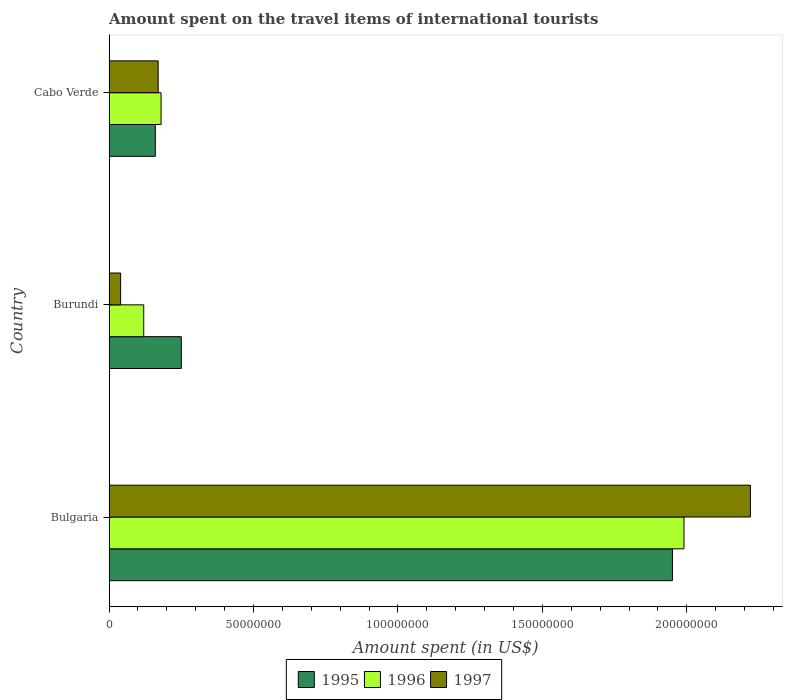How many different coloured bars are there?
Give a very brief answer. 3. How many groups of bars are there?
Your answer should be very brief. 3. Are the number of bars per tick equal to the number of legend labels?
Your answer should be compact. Yes. How many bars are there on the 2nd tick from the bottom?
Provide a short and direct response. 3. What is the label of the 2nd group of bars from the top?
Your answer should be very brief. Burundi. In how many cases, is the number of bars for a given country not equal to the number of legend labels?
Keep it short and to the point. 0. What is the amount spent on the travel items of international tourists in 1997 in Cabo Verde?
Offer a very short reply. 1.70e+07. Across all countries, what is the maximum amount spent on the travel items of international tourists in 1997?
Your answer should be very brief. 2.22e+08. Across all countries, what is the minimum amount spent on the travel items of international tourists in 1996?
Your response must be concise. 1.20e+07. In which country was the amount spent on the travel items of international tourists in 1996 minimum?
Your response must be concise. Burundi. What is the total amount spent on the travel items of international tourists in 1997 in the graph?
Provide a short and direct response. 2.43e+08. What is the difference between the amount spent on the travel items of international tourists in 1997 in Bulgaria and that in Cabo Verde?
Your response must be concise. 2.05e+08. What is the difference between the amount spent on the travel items of international tourists in 1995 in Burundi and the amount spent on the travel items of international tourists in 1997 in Cabo Verde?
Ensure brevity in your answer.  8.00e+06. What is the average amount spent on the travel items of international tourists in 1997 per country?
Keep it short and to the point. 8.10e+07. What is the difference between the amount spent on the travel items of international tourists in 1995 and amount spent on the travel items of international tourists in 1996 in Bulgaria?
Provide a short and direct response. -4.00e+06. In how many countries, is the amount spent on the travel items of international tourists in 1997 greater than 100000000 US$?
Your response must be concise. 1. What is the ratio of the amount spent on the travel items of international tourists in 1997 in Bulgaria to that in Burundi?
Your answer should be compact. 55.5. Is the amount spent on the travel items of international tourists in 1995 in Burundi less than that in Cabo Verde?
Provide a succinct answer. No. Is the difference between the amount spent on the travel items of international tourists in 1995 in Bulgaria and Cabo Verde greater than the difference between the amount spent on the travel items of international tourists in 1996 in Bulgaria and Cabo Verde?
Give a very brief answer. No. What is the difference between the highest and the second highest amount spent on the travel items of international tourists in 1996?
Offer a very short reply. 1.81e+08. What is the difference between the highest and the lowest amount spent on the travel items of international tourists in 1996?
Offer a very short reply. 1.87e+08. How many bars are there?
Provide a succinct answer. 9. How many countries are there in the graph?
Your answer should be very brief. 3. What is the difference between two consecutive major ticks on the X-axis?
Provide a succinct answer. 5.00e+07. Are the values on the major ticks of X-axis written in scientific E-notation?
Provide a succinct answer. No. How many legend labels are there?
Make the answer very short. 3. What is the title of the graph?
Your answer should be very brief. Amount spent on the travel items of international tourists. Does "1991" appear as one of the legend labels in the graph?
Your answer should be compact. No. What is the label or title of the X-axis?
Ensure brevity in your answer.  Amount spent (in US$). What is the Amount spent (in US$) of 1995 in Bulgaria?
Your response must be concise. 1.95e+08. What is the Amount spent (in US$) of 1996 in Bulgaria?
Your response must be concise. 1.99e+08. What is the Amount spent (in US$) in 1997 in Bulgaria?
Your answer should be compact. 2.22e+08. What is the Amount spent (in US$) of 1995 in Burundi?
Keep it short and to the point. 2.50e+07. What is the Amount spent (in US$) of 1997 in Burundi?
Your response must be concise. 4.00e+06. What is the Amount spent (in US$) of 1995 in Cabo Verde?
Your answer should be compact. 1.60e+07. What is the Amount spent (in US$) of 1996 in Cabo Verde?
Ensure brevity in your answer.  1.80e+07. What is the Amount spent (in US$) of 1997 in Cabo Verde?
Provide a succinct answer. 1.70e+07. Across all countries, what is the maximum Amount spent (in US$) in 1995?
Ensure brevity in your answer.  1.95e+08. Across all countries, what is the maximum Amount spent (in US$) of 1996?
Offer a very short reply. 1.99e+08. Across all countries, what is the maximum Amount spent (in US$) of 1997?
Offer a very short reply. 2.22e+08. Across all countries, what is the minimum Amount spent (in US$) of 1995?
Give a very brief answer. 1.60e+07. Across all countries, what is the minimum Amount spent (in US$) in 1996?
Keep it short and to the point. 1.20e+07. What is the total Amount spent (in US$) in 1995 in the graph?
Offer a very short reply. 2.36e+08. What is the total Amount spent (in US$) of 1996 in the graph?
Ensure brevity in your answer.  2.29e+08. What is the total Amount spent (in US$) of 1997 in the graph?
Offer a terse response. 2.43e+08. What is the difference between the Amount spent (in US$) of 1995 in Bulgaria and that in Burundi?
Keep it short and to the point. 1.70e+08. What is the difference between the Amount spent (in US$) of 1996 in Bulgaria and that in Burundi?
Give a very brief answer. 1.87e+08. What is the difference between the Amount spent (in US$) of 1997 in Bulgaria and that in Burundi?
Your response must be concise. 2.18e+08. What is the difference between the Amount spent (in US$) in 1995 in Bulgaria and that in Cabo Verde?
Offer a terse response. 1.79e+08. What is the difference between the Amount spent (in US$) of 1996 in Bulgaria and that in Cabo Verde?
Offer a very short reply. 1.81e+08. What is the difference between the Amount spent (in US$) of 1997 in Bulgaria and that in Cabo Verde?
Your answer should be compact. 2.05e+08. What is the difference between the Amount spent (in US$) in 1995 in Burundi and that in Cabo Verde?
Provide a succinct answer. 9.00e+06. What is the difference between the Amount spent (in US$) in 1996 in Burundi and that in Cabo Verde?
Your response must be concise. -6.00e+06. What is the difference between the Amount spent (in US$) of 1997 in Burundi and that in Cabo Verde?
Make the answer very short. -1.30e+07. What is the difference between the Amount spent (in US$) of 1995 in Bulgaria and the Amount spent (in US$) of 1996 in Burundi?
Keep it short and to the point. 1.83e+08. What is the difference between the Amount spent (in US$) of 1995 in Bulgaria and the Amount spent (in US$) of 1997 in Burundi?
Your response must be concise. 1.91e+08. What is the difference between the Amount spent (in US$) in 1996 in Bulgaria and the Amount spent (in US$) in 1997 in Burundi?
Your answer should be very brief. 1.95e+08. What is the difference between the Amount spent (in US$) in 1995 in Bulgaria and the Amount spent (in US$) in 1996 in Cabo Verde?
Make the answer very short. 1.77e+08. What is the difference between the Amount spent (in US$) of 1995 in Bulgaria and the Amount spent (in US$) of 1997 in Cabo Verde?
Your answer should be very brief. 1.78e+08. What is the difference between the Amount spent (in US$) in 1996 in Bulgaria and the Amount spent (in US$) in 1997 in Cabo Verde?
Your response must be concise. 1.82e+08. What is the difference between the Amount spent (in US$) in 1995 in Burundi and the Amount spent (in US$) in 1996 in Cabo Verde?
Your answer should be very brief. 7.00e+06. What is the difference between the Amount spent (in US$) in 1996 in Burundi and the Amount spent (in US$) in 1997 in Cabo Verde?
Provide a short and direct response. -5.00e+06. What is the average Amount spent (in US$) of 1995 per country?
Your response must be concise. 7.87e+07. What is the average Amount spent (in US$) in 1996 per country?
Ensure brevity in your answer.  7.63e+07. What is the average Amount spent (in US$) in 1997 per country?
Your answer should be compact. 8.10e+07. What is the difference between the Amount spent (in US$) in 1995 and Amount spent (in US$) in 1996 in Bulgaria?
Your response must be concise. -4.00e+06. What is the difference between the Amount spent (in US$) of 1995 and Amount spent (in US$) of 1997 in Bulgaria?
Offer a terse response. -2.70e+07. What is the difference between the Amount spent (in US$) in 1996 and Amount spent (in US$) in 1997 in Bulgaria?
Give a very brief answer. -2.30e+07. What is the difference between the Amount spent (in US$) in 1995 and Amount spent (in US$) in 1996 in Burundi?
Provide a succinct answer. 1.30e+07. What is the difference between the Amount spent (in US$) in 1995 and Amount spent (in US$) in 1997 in Burundi?
Offer a terse response. 2.10e+07. What is the difference between the Amount spent (in US$) in 1995 and Amount spent (in US$) in 1997 in Cabo Verde?
Give a very brief answer. -1.00e+06. What is the difference between the Amount spent (in US$) in 1996 and Amount spent (in US$) in 1997 in Cabo Verde?
Give a very brief answer. 1.00e+06. What is the ratio of the Amount spent (in US$) of 1995 in Bulgaria to that in Burundi?
Provide a succinct answer. 7.8. What is the ratio of the Amount spent (in US$) in 1996 in Bulgaria to that in Burundi?
Your answer should be compact. 16.58. What is the ratio of the Amount spent (in US$) of 1997 in Bulgaria to that in Burundi?
Offer a terse response. 55.5. What is the ratio of the Amount spent (in US$) in 1995 in Bulgaria to that in Cabo Verde?
Provide a short and direct response. 12.19. What is the ratio of the Amount spent (in US$) in 1996 in Bulgaria to that in Cabo Verde?
Give a very brief answer. 11.06. What is the ratio of the Amount spent (in US$) of 1997 in Bulgaria to that in Cabo Verde?
Offer a very short reply. 13.06. What is the ratio of the Amount spent (in US$) of 1995 in Burundi to that in Cabo Verde?
Give a very brief answer. 1.56. What is the ratio of the Amount spent (in US$) of 1996 in Burundi to that in Cabo Verde?
Offer a terse response. 0.67. What is the ratio of the Amount spent (in US$) of 1997 in Burundi to that in Cabo Verde?
Offer a terse response. 0.24. What is the difference between the highest and the second highest Amount spent (in US$) of 1995?
Your answer should be very brief. 1.70e+08. What is the difference between the highest and the second highest Amount spent (in US$) of 1996?
Provide a short and direct response. 1.81e+08. What is the difference between the highest and the second highest Amount spent (in US$) in 1997?
Ensure brevity in your answer.  2.05e+08. What is the difference between the highest and the lowest Amount spent (in US$) of 1995?
Offer a very short reply. 1.79e+08. What is the difference between the highest and the lowest Amount spent (in US$) of 1996?
Your response must be concise. 1.87e+08. What is the difference between the highest and the lowest Amount spent (in US$) of 1997?
Your answer should be very brief. 2.18e+08. 